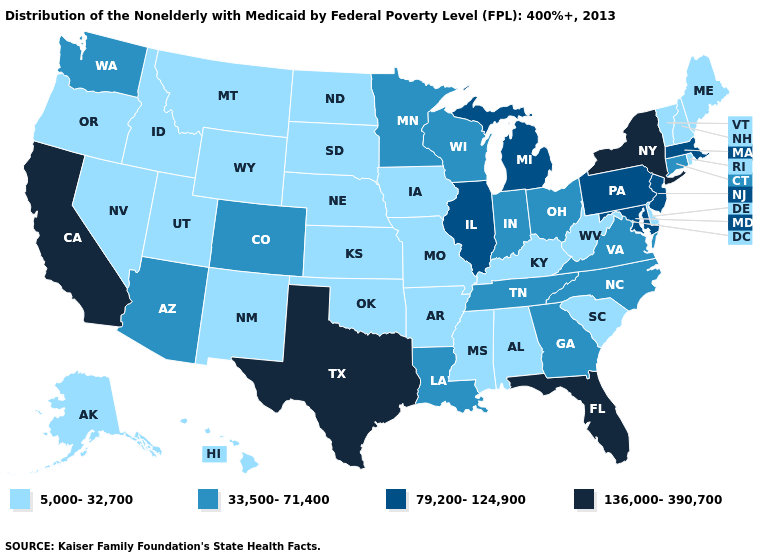Does Vermont have the lowest value in the USA?
Be succinct. Yes. Among the states that border Kansas , which have the highest value?
Concise answer only. Colorado. What is the value of North Dakota?
Be succinct. 5,000-32,700. What is the value of Connecticut?
Write a very short answer. 33,500-71,400. Among the states that border Arkansas , does Texas have the lowest value?
Answer briefly. No. Does Hawaii have the same value as Virginia?
Answer briefly. No. Does the map have missing data?
Be succinct. No. What is the value of South Carolina?
Short answer required. 5,000-32,700. Does New Hampshire have the highest value in the USA?
Write a very short answer. No. What is the value of North Dakota?
Give a very brief answer. 5,000-32,700. What is the highest value in the USA?
Quick response, please. 136,000-390,700. Which states have the lowest value in the South?
Keep it brief. Alabama, Arkansas, Delaware, Kentucky, Mississippi, Oklahoma, South Carolina, West Virginia. Name the states that have a value in the range 33,500-71,400?
Write a very short answer. Arizona, Colorado, Connecticut, Georgia, Indiana, Louisiana, Minnesota, North Carolina, Ohio, Tennessee, Virginia, Washington, Wisconsin. Name the states that have a value in the range 33,500-71,400?
Give a very brief answer. Arizona, Colorado, Connecticut, Georgia, Indiana, Louisiana, Minnesota, North Carolina, Ohio, Tennessee, Virginia, Washington, Wisconsin. What is the value of Tennessee?
Quick response, please. 33,500-71,400. 